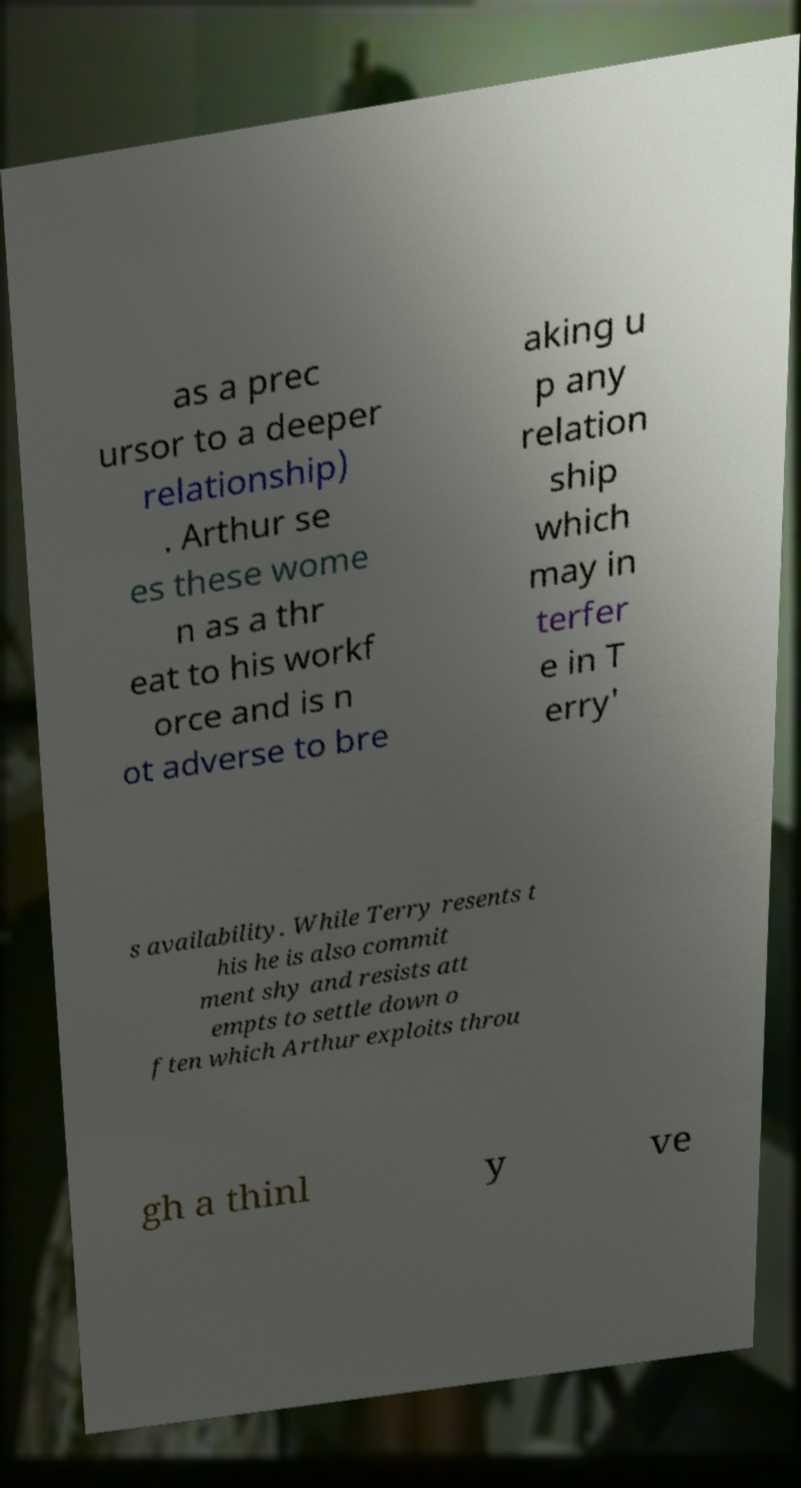Please read and relay the text visible in this image. What does it say? as a prec ursor to a deeper relationship) . Arthur se es these wome n as a thr eat to his workf orce and is n ot adverse to bre aking u p any relation ship which may in terfer e in T erry' s availability. While Terry resents t his he is also commit ment shy and resists att empts to settle down o ften which Arthur exploits throu gh a thinl y ve 